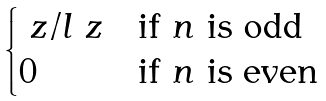<formula> <loc_0><loc_0><loc_500><loc_500>\begin{cases} \ z / l \ z & \text {if $n$ is odd} \\ 0 & \text {if $n$ is even} \end{cases}</formula> 